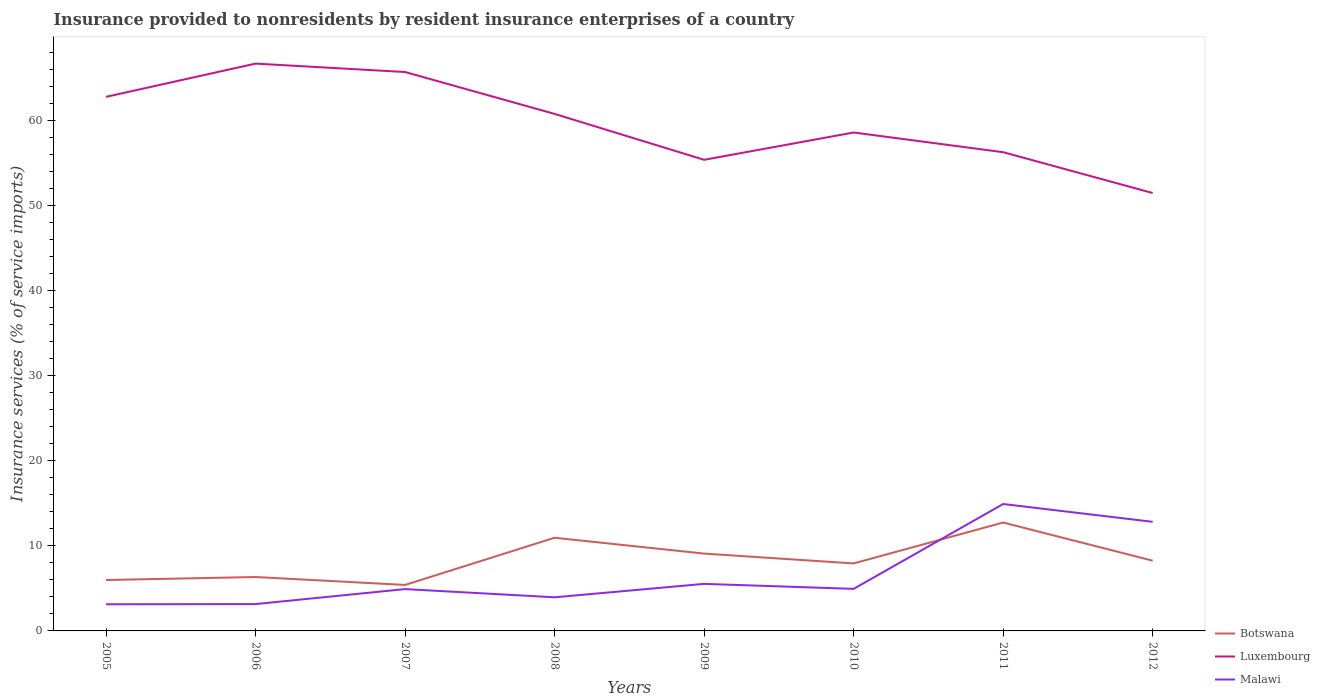How many different coloured lines are there?
Make the answer very short. 3. Across all years, what is the maximum insurance provided to nonresidents in Botswana?
Make the answer very short. 5.41. What is the total insurance provided to nonresidents in Malawi in the graph?
Provide a short and direct response. -11.77. What is the difference between the highest and the second highest insurance provided to nonresidents in Malawi?
Your response must be concise. 11.79. Is the insurance provided to nonresidents in Luxembourg strictly greater than the insurance provided to nonresidents in Malawi over the years?
Your response must be concise. No. What is the difference between two consecutive major ticks on the Y-axis?
Offer a very short reply. 10. Are the values on the major ticks of Y-axis written in scientific E-notation?
Your response must be concise. No. Does the graph contain any zero values?
Give a very brief answer. No. Where does the legend appear in the graph?
Provide a short and direct response. Bottom right. What is the title of the graph?
Your answer should be compact. Insurance provided to nonresidents by resident insurance enterprises of a country. What is the label or title of the Y-axis?
Your answer should be very brief. Insurance services (% of service imports). What is the Insurance services (% of service imports) of Botswana in 2005?
Give a very brief answer. 5.99. What is the Insurance services (% of service imports) in Luxembourg in 2005?
Keep it short and to the point. 62.82. What is the Insurance services (% of service imports) in Malawi in 2005?
Ensure brevity in your answer.  3.13. What is the Insurance services (% of service imports) in Botswana in 2006?
Offer a very short reply. 6.34. What is the Insurance services (% of service imports) in Luxembourg in 2006?
Offer a very short reply. 66.73. What is the Insurance services (% of service imports) of Malawi in 2006?
Make the answer very short. 3.16. What is the Insurance services (% of service imports) in Botswana in 2007?
Your answer should be very brief. 5.41. What is the Insurance services (% of service imports) in Luxembourg in 2007?
Ensure brevity in your answer.  65.74. What is the Insurance services (% of service imports) of Malawi in 2007?
Ensure brevity in your answer.  4.92. What is the Insurance services (% of service imports) in Botswana in 2008?
Give a very brief answer. 10.96. What is the Insurance services (% of service imports) of Luxembourg in 2008?
Provide a short and direct response. 60.81. What is the Insurance services (% of service imports) of Malawi in 2008?
Keep it short and to the point. 3.95. What is the Insurance services (% of service imports) in Botswana in 2009?
Offer a terse response. 9.1. What is the Insurance services (% of service imports) in Luxembourg in 2009?
Ensure brevity in your answer.  55.41. What is the Insurance services (% of service imports) in Malawi in 2009?
Provide a succinct answer. 5.53. What is the Insurance services (% of service imports) in Botswana in 2010?
Offer a very short reply. 7.94. What is the Insurance services (% of service imports) of Luxembourg in 2010?
Keep it short and to the point. 58.63. What is the Insurance services (% of service imports) in Malawi in 2010?
Your answer should be compact. 4.95. What is the Insurance services (% of service imports) of Botswana in 2011?
Offer a terse response. 12.75. What is the Insurance services (% of service imports) of Luxembourg in 2011?
Provide a succinct answer. 56.31. What is the Insurance services (% of service imports) of Malawi in 2011?
Offer a terse response. 14.93. What is the Insurance services (% of service imports) of Botswana in 2012?
Make the answer very short. 8.26. What is the Insurance services (% of service imports) in Luxembourg in 2012?
Your answer should be compact. 51.51. What is the Insurance services (% of service imports) in Malawi in 2012?
Keep it short and to the point. 12.83. Across all years, what is the maximum Insurance services (% of service imports) of Botswana?
Give a very brief answer. 12.75. Across all years, what is the maximum Insurance services (% of service imports) of Luxembourg?
Give a very brief answer. 66.73. Across all years, what is the maximum Insurance services (% of service imports) of Malawi?
Your response must be concise. 14.93. Across all years, what is the minimum Insurance services (% of service imports) of Botswana?
Keep it short and to the point. 5.41. Across all years, what is the minimum Insurance services (% of service imports) of Luxembourg?
Your response must be concise. 51.51. Across all years, what is the minimum Insurance services (% of service imports) in Malawi?
Offer a terse response. 3.13. What is the total Insurance services (% of service imports) in Botswana in the graph?
Your response must be concise. 66.74. What is the total Insurance services (% of service imports) of Luxembourg in the graph?
Provide a succinct answer. 477.96. What is the total Insurance services (% of service imports) in Malawi in the graph?
Make the answer very short. 53.41. What is the difference between the Insurance services (% of service imports) of Botswana in 2005 and that in 2006?
Provide a succinct answer. -0.35. What is the difference between the Insurance services (% of service imports) of Luxembourg in 2005 and that in 2006?
Ensure brevity in your answer.  -3.91. What is the difference between the Insurance services (% of service imports) in Malawi in 2005 and that in 2006?
Ensure brevity in your answer.  -0.02. What is the difference between the Insurance services (% of service imports) in Botswana in 2005 and that in 2007?
Give a very brief answer. 0.58. What is the difference between the Insurance services (% of service imports) of Luxembourg in 2005 and that in 2007?
Offer a very short reply. -2.92. What is the difference between the Insurance services (% of service imports) in Malawi in 2005 and that in 2007?
Your response must be concise. -1.78. What is the difference between the Insurance services (% of service imports) of Botswana in 2005 and that in 2008?
Your response must be concise. -4.97. What is the difference between the Insurance services (% of service imports) in Luxembourg in 2005 and that in 2008?
Give a very brief answer. 2.01. What is the difference between the Insurance services (% of service imports) in Malawi in 2005 and that in 2008?
Make the answer very short. -0.82. What is the difference between the Insurance services (% of service imports) of Botswana in 2005 and that in 2009?
Provide a short and direct response. -3.11. What is the difference between the Insurance services (% of service imports) in Luxembourg in 2005 and that in 2009?
Make the answer very short. 7.4. What is the difference between the Insurance services (% of service imports) of Malawi in 2005 and that in 2009?
Keep it short and to the point. -2.4. What is the difference between the Insurance services (% of service imports) in Botswana in 2005 and that in 2010?
Your response must be concise. -1.95. What is the difference between the Insurance services (% of service imports) in Luxembourg in 2005 and that in 2010?
Your answer should be compact. 4.19. What is the difference between the Insurance services (% of service imports) in Malawi in 2005 and that in 2010?
Provide a succinct answer. -1.81. What is the difference between the Insurance services (% of service imports) in Botswana in 2005 and that in 2011?
Give a very brief answer. -6.76. What is the difference between the Insurance services (% of service imports) of Luxembourg in 2005 and that in 2011?
Ensure brevity in your answer.  6.51. What is the difference between the Insurance services (% of service imports) of Malawi in 2005 and that in 2011?
Keep it short and to the point. -11.79. What is the difference between the Insurance services (% of service imports) in Botswana in 2005 and that in 2012?
Offer a terse response. -2.27. What is the difference between the Insurance services (% of service imports) of Luxembourg in 2005 and that in 2012?
Provide a short and direct response. 11.31. What is the difference between the Insurance services (% of service imports) in Malawi in 2005 and that in 2012?
Your response must be concise. -9.7. What is the difference between the Insurance services (% of service imports) in Botswana in 2006 and that in 2007?
Make the answer very short. 0.93. What is the difference between the Insurance services (% of service imports) of Luxembourg in 2006 and that in 2007?
Offer a terse response. 0.99. What is the difference between the Insurance services (% of service imports) in Malawi in 2006 and that in 2007?
Give a very brief answer. -1.76. What is the difference between the Insurance services (% of service imports) of Botswana in 2006 and that in 2008?
Give a very brief answer. -4.62. What is the difference between the Insurance services (% of service imports) of Luxembourg in 2006 and that in 2008?
Make the answer very short. 5.92. What is the difference between the Insurance services (% of service imports) of Malawi in 2006 and that in 2008?
Give a very brief answer. -0.8. What is the difference between the Insurance services (% of service imports) of Botswana in 2006 and that in 2009?
Offer a very short reply. -2.76. What is the difference between the Insurance services (% of service imports) of Luxembourg in 2006 and that in 2009?
Keep it short and to the point. 11.32. What is the difference between the Insurance services (% of service imports) in Malawi in 2006 and that in 2009?
Keep it short and to the point. -2.38. What is the difference between the Insurance services (% of service imports) of Botswana in 2006 and that in 2010?
Your response must be concise. -1.6. What is the difference between the Insurance services (% of service imports) of Luxembourg in 2006 and that in 2010?
Make the answer very short. 8.1. What is the difference between the Insurance services (% of service imports) of Malawi in 2006 and that in 2010?
Make the answer very short. -1.79. What is the difference between the Insurance services (% of service imports) in Botswana in 2006 and that in 2011?
Offer a terse response. -6.41. What is the difference between the Insurance services (% of service imports) in Luxembourg in 2006 and that in 2011?
Keep it short and to the point. 10.42. What is the difference between the Insurance services (% of service imports) of Malawi in 2006 and that in 2011?
Offer a terse response. -11.77. What is the difference between the Insurance services (% of service imports) in Botswana in 2006 and that in 2012?
Your response must be concise. -1.92. What is the difference between the Insurance services (% of service imports) of Luxembourg in 2006 and that in 2012?
Provide a succinct answer. 15.22. What is the difference between the Insurance services (% of service imports) of Malawi in 2006 and that in 2012?
Offer a terse response. -9.68. What is the difference between the Insurance services (% of service imports) in Botswana in 2007 and that in 2008?
Offer a terse response. -5.55. What is the difference between the Insurance services (% of service imports) of Luxembourg in 2007 and that in 2008?
Offer a very short reply. 4.93. What is the difference between the Insurance services (% of service imports) in Malawi in 2007 and that in 2008?
Your answer should be compact. 0.96. What is the difference between the Insurance services (% of service imports) in Botswana in 2007 and that in 2009?
Ensure brevity in your answer.  -3.69. What is the difference between the Insurance services (% of service imports) of Luxembourg in 2007 and that in 2009?
Ensure brevity in your answer.  10.33. What is the difference between the Insurance services (% of service imports) in Malawi in 2007 and that in 2009?
Give a very brief answer. -0.62. What is the difference between the Insurance services (% of service imports) in Botswana in 2007 and that in 2010?
Ensure brevity in your answer.  -2.53. What is the difference between the Insurance services (% of service imports) of Luxembourg in 2007 and that in 2010?
Offer a very short reply. 7.11. What is the difference between the Insurance services (% of service imports) of Malawi in 2007 and that in 2010?
Provide a succinct answer. -0.03. What is the difference between the Insurance services (% of service imports) in Botswana in 2007 and that in 2011?
Ensure brevity in your answer.  -7.34. What is the difference between the Insurance services (% of service imports) of Luxembourg in 2007 and that in 2011?
Make the answer very short. 9.43. What is the difference between the Insurance services (% of service imports) of Malawi in 2007 and that in 2011?
Make the answer very short. -10.01. What is the difference between the Insurance services (% of service imports) in Botswana in 2007 and that in 2012?
Keep it short and to the point. -2.85. What is the difference between the Insurance services (% of service imports) of Luxembourg in 2007 and that in 2012?
Offer a terse response. 14.23. What is the difference between the Insurance services (% of service imports) in Malawi in 2007 and that in 2012?
Offer a terse response. -7.91. What is the difference between the Insurance services (% of service imports) of Botswana in 2008 and that in 2009?
Offer a very short reply. 1.86. What is the difference between the Insurance services (% of service imports) in Luxembourg in 2008 and that in 2009?
Your response must be concise. 5.4. What is the difference between the Insurance services (% of service imports) in Malawi in 2008 and that in 2009?
Give a very brief answer. -1.58. What is the difference between the Insurance services (% of service imports) of Botswana in 2008 and that in 2010?
Provide a short and direct response. 3.02. What is the difference between the Insurance services (% of service imports) of Luxembourg in 2008 and that in 2010?
Provide a short and direct response. 2.19. What is the difference between the Insurance services (% of service imports) in Malawi in 2008 and that in 2010?
Keep it short and to the point. -0.99. What is the difference between the Insurance services (% of service imports) in Botswana in 2008 and that in 2011?
Ensure brevity in your answer.  -1.79. What is the difference between the Insurance services (% of service imports) in Luxembourg in 2008 and that in 2011?
Your answer should be compact. 4.5. What is the difference between the Insurance services (% of service imports) in Malawi in 2008 and that in 2011?
Provide a short and direct response. -10.97. What is the difference between the Insurance services (% of service imports) of Botswana in 2008 and that in 2012?
Your answer should be compact. 2.7. What is the difference between the Insurance services (% of service imports) in Luxembourg in 2008 and that in 2012?
Your answer should be compact. 9.31. What is the difference between the Insurance services (% of service imports) of Malawi in 2008 and that in 2012?
Your response must be concise. -8.88. What is the difference between the Insurance services (% of service imports) of Botswana in 2009 and that in 2010?
Your answer should be very brief. 1.16. What is the difference between the Insurance services (% of service imports) of Luxembourg in 2009 and that in 2010?
Ensure brevity in your answer.  -3.21. What is the difference between the Insurance services (% of service imports) of Malawi in 2009 and that in 2010?
Your response must be concise. 0.59. What is the difference between the Insurance services (% of service imports) of Botswana in 2009 and that in 2011?
Ensure brevity in your answer.  -3.65. What is the difference between the Insurance services (% of service imports) of Luxembourg in 2009 and that in 2011?
Your response must be concise. -0.9. What is the difference between the Insurance services (% of service imports) of Malawi in 2009 and that in 2011?
Keep it short and to the point. -9.39. What is the difference between the Insurance services (% of service imports) of Botswana in 2009 and that in 2012?
Your answer should be compact. 0.83. What is the difference between the Insurance services (% of service imports) of Luxembourg in 2009 and that in 2012?
Offer a very short reply. 3.91. What is the difference between the Insurance services (% of service imports) in Malawi in 2009 and that in 2012?
Provide a short and direct response. -7.3. What is the difference between the Insurance services (% of service imports) in Botswana in 2010 and that in 2011?
Your answer should be compact. -4.81. What is the difference between the Insurance services (% of service imports) in Luxembourg in 2010 and that in 2011?
Ensure brevity in your answer.  2.32. What is the difference between the Insurance services (% of service imports) of Malawi in 2010 and that in 2011?
Give a very brief answer. -9.98. What is the difference between the Insurance services (% of service imports) in Botswana in 2010 and that in 2012?
Offer a very short reply. -0.32. What is the difference between the Insurance services (% of service imports) of Luxembourg in 2010 and that in 2012?
Your response must be concise. 7.12. What is the difference between the Insurance services (% of service imports) in Malawi in 2010 and that in 2012?
Keep it short and to the point. -7.89. What is the difference between the Insurance services (% of service imports) of Botswana in 2011 and that in 2012?
Give a very brief answer. 4.49. What is the difference between the Insurance services (% of service imports) in Luxembourg in 2011 and that in 2012?
Keep it short and to the point. 4.8. What is the difference between the Insurance services (% of service imports) in Malawi in 2011 and that in 2012?
Make the answer very short. 2.09. What is the difference between the Insurance services (% of service imports) of Botswana in 2005 and the Insurance services (% of service imports) of Luxembourg in 2006?
Give a very brief answer. -60.74. What is the difference between the Insurance services (% of service imports) of Botswana in 2005 and the Insurance services (% of service imports) of Malawi in 2006?
Keep it short and to the point. 2.83. What is the difference between the Insurance services (% of service imports) of Luxembourg in 2005 and the Insurance services (% of service imports) of Malawi in 2006?
Keep it short and to the point. 59.66. What is the difference between the Insurance services (% of service imports) in Botswana in 2005 and the Insurance services (% of service imports) in Luxembourg in 2007?
Give a very brief answer. -59.75. What is the difference between the Insurance services (% of service imports) in Botswana in 2005 and the Insurance services (% of service imports) in Malawi in 2007?
Offer a terse response. 1.07. What is the difference between the Insurance services (% of service imports) in Luxembourg in 2005 and the Insurance services (% of service imports) in Malawi in 2007?
Keep it short and to the point. 57.9. What is the difference between the Insurance services (% of service imports) in Botswana in 2005 and the Insurance services (% of service imports) in Luxembourg in 2008?
Your answer should be compact. -54.83. What is the difference between the Insurance services (% of service imports) of Botswana in 2005 and the Insurance services (% of service imports) of Malawi in 2008?
Give a very brief answer. 2.03. What is the difference between the Insurance services (% of service imports) in Luxembourg in 2005 and the Insurance services (% of service imports) in Malawi in 2008?
Provide a short and direct response. 58.86. What is the difference between the Insurance services (% of service imports) of Botswana in 2005 and the Insurance services (% of service imports) of Luxembourg in 2009?
Give a very brief answer. -49.43. What is the difference between the Insurance services (% of service imports) in Botswana in 2005 and the Insurance services (% of service imports) in Malawi in 2009?
Keep it short and to the point. 0.45. What is the difference between the Insurance services (% of service imports) of Luxembourg in 2005 and the Insurance services (% of service imports) of Malawi in 2009?
Provide a short and direct response. 57.28. What is the difference between the Insurance services (% of service imports) of Botswana in 2005 and the Insurance services (% of service imports) of Luxembourg in 2010?
Offer a very short reply. -52.64. What is the difference between the Insurance services (% of service imports) of Botswana in 2005 and the Insurance services (% of service imports) of Malawi in 2010?
Make the answer very short. 1.04. What is the difference between the Insurance services (% of service imports) in Luxembourg in 2005 and the Insurance services (% of service imports) in Malawi in 2010?
Keep it short and to the point. 57.87. What is the difference between the Insurance services (% of service imports) in Botswana in 2005 and the Insurance services (% of service imports) in Luxembourg in 2011?
Your answer should be very brief. -50.32. What is the difference between the Insurance services (% of service imports) in Botswana in 2005 and the Insurance services (% of service imports) in Malawi in 2011?
Offer a very short reply. -8.94. What is the difference between the Insurance services (% of service imports) of Luxembourg in 2005 and the Insurance services (% of service imports) of Malawi in 2011?
Make the answer very short. 47.89. What is the difference between the Insurance services (% of service imports) in Botswana in 2005 and the Insurance services (% of service imports) in Luxembourg in 2012?
Offer a very short reply. -45.52. What is the difference between the Insurance services (% of service imports) of Botswana in 2005 and the Insurance services (% of service imports) of Malawi in 2012?
Your response must be concise. -6.85. What is the difference between the Insurance services (% of service imports) in Luxembourg in 2005 and the Insurance services (% of service imports) in Malawi in 2012?
Your answer should be very brief. 49.99. What is the difference between the Insurance services (% of service imports) in Botswana in 2006 and the Insurance services (% of service imports) in Luxembourg in 2007?
Your answer should be very brief. -59.4. What is the difference between the Insurance services (% of service imports) of Botswana in 2006 and the Insurance services (% of service imports) of Malawi in 2007?
Provide a short and direct response. 1.42. What is the difference between the Insurance services (% of service imports) in Luxembourg in 2006 and the Insurance services (% of service imports) in Malawi in 2007?
Your answer should be very brief. 61.81. What is the difference between the Insurance services (% of service imports) in Botswana in 2006 and the Insurance services (% of service imports) in Luxembourg in 2008?
Provide a short and direct response. -54.47. What is the difference between the Insurance services (% of service imports) of Botswana in 2006 and the Insurance services (% of service imports) of Malawi in 2008?
Provide a short and direct response. 2.39. What is the difference between the Insurance services (% of service imports) of Luxembourg in 2006 and the Insurance services (% of service imports) of Malawi in 2008?
Offer a terse response. 62.78. What is the difference between the Insurance services (% of service imports) of Botswana in 2006 and the Insurance services (% of service imports) of Luxembourg in 2009?
Provide a succinct answer. -49.07. What is the difference between the Insurance services (% of service imports) in Botswana in 2006 and the Insurance services (% of service imports) in Malawi in 2009?
Make the answer very short. 0.81. What is the difference between the Insurance services (% of service imports) in Luxembourg in 2006 and the Insurance services (% of service imports) in Malawi in 2009?
Provide a succinct answer. 61.2. What is the difference between the Insurance services (% of service imports) in Botswana in 2006 and the Insurance services (% of service imports) in Luxembourg in 2010?
Your answer should be compact. -52.29. What is the difference between the Insurance services (% of service imports) of Botswana in 2006 and the Insurance services (% of service imports) of Malawi in 2010?
Your response must be concise. 1.39. What is the difference between the Insurance services (% of service imports) in Luxembourg in 2006 and the Insurance services (% of service imports) in Malawi in 2010?
Ensure brevity in your answer.  61.78. What is the difference between the Insurance services (% of service imports) of Botswana in 2006 and the Insurance services (% of service imports) of Luxembourg in 2011?
Ensure brevity in your answer.  -49.97. What is the difference between the Insurance services (% of service imports) in Botswana in 2006 and the Insurance services (% of service imports) in Malawi in 2011?
Keep it short and to the point. -8.59. What is the difference between the Insurance services (% of service imports) in Luxembourg in 2006 and the Insurance services (% of service imports) in Malawi in 2011?
Provide a succinct answer. 51.8. What is the difference between the Insurance services (% of service imports) of Botswana in 2006 and the Insurance services (% of service imports) of Luxembourg in 2012?
Your answer should be compact. -45.17. What is the difference between the Insurance services (% of service imports) of Botswana in 2006 and the Insurance services (% of service imports) of Malawi in 2012?
Provide a short and direct response. -6.49. What is the difference between the Insurance services (% of service imports) in Luxembourg in 2006 and the Insurance services (% of service imports) in Malawi in 2012?
Give a very brief answer. 53.9. What is the difference between the Insurance services (% of service imports) in Botswana in 2007 and the Insurance services (% of service imports) in Luxembourg in 2008?
Your response must be concise. -55.41. What is the difference between the Insurance services (% of service imports) of Botswana in 2007 and the Insurance services (% of service imports) of Malawi in 2008?
Your response must be concise. 1.45. What is the difference between the Insurance services (% of service imports) of Luxembourg in 2007 and the Insurance services (% of service imports) of Malawi in 2008?
Your response must be concise. 61.79. What is the difference between the Insurance services (% of service imports) in Botswana in 2007 and the Insurance services (% of service imports) in Luxembourg in 2009?
Give a very brief answer. -50.01. What is the difference between the Insurance services (% of service imports) in Botswana in 2007 and the Insurance services (% of service imports) in Malawi in 2009?
Your answer should be very brief. -0.13. What is the difference between the Insurance services (% of service imports) in Luxembourg in 2007 and the Insurance services (% of service imports) in Malawi in 2009?
Make the answer very short. 60.21. What is the difference between the Insurance services (% of service imports) in Botswana in 2007 and the Insurance services (% of service imports) in Luxembourg in 2010?
Your response must be concise. -53.22. What is the difference between the Insurance services (% of service imports) of Botswana in 2007 and the Insurance services (% of service imports) of Malawi in 2010?
Make the answer very short. 0.46. What is the difference between the Insurance services (% of service imports) in Luxembourg in 2007 and the Insurance services (% of service imports) in Malawi in 2010?
Offer a very short reply. 60.79. What is the difference between the Insurance services (% of service imports) of Botswana in 2007 and the Insurance services (% of service imports) of Luxembourg in 2011?
Your response must be concise. -50.9. What is the difference between the Insurance services (% of service imports) in Botswana in 2007 and the Insurance services (% of service imports) in Malawi in 2011?
Your answer should be compact. -9.52. What is the difference between the Insurance services (% of service imports) in Luxembourg in 2007 and the Insurance services (% of service imports) in Malawi in 2011?
Offer a very short reply. 50.81. What is the difference between the Insurance services (% of service imports) in Botswana in 2007 and the Insurance services (% of service imports) in Luxembourg in 2012?
Your answer should be compact. -46.1. What is the difference between the Insurance services (% of service imports) of Botswana in 2007 and the Insurance services (% of service imports) of Malawi in 2012?
Provide a succinct answer. -7.42. What is the difference between the Insurance services (% of service imports) in Luxembourg in 2007 and the Insurance services (% of service imports) in Malawi in 2012?
Your answer should be very brief. 52.91. What is the difference between the Insurance services (% of service imports) in Botswana in 2008 and the Insurance services (% of service imports) in Luxembourg in 2009?
Keep it short and to the point. -44.46. What is the difference between the Insurance services (% of service imports) in Botswana in 2008 and the Insurance services (% of service imports) in Malawi in 2009?
Your answer should be very brief. 5.43. What is the difference between the Insurance services (% of service imports) in Luxembourg in 2008 and the Insurance services (% of service imports) in Malawi in 2009?
Make the answer very short. 55.28. What is the difference between the Insurance services (% of service imports) in Botswana in 2008 and the Insurance services (% of service imports) in Luxembourg in 2010?
Offer a terse response. -47.67. What is the difference between the Insurance services (% of service imports) of Botswana in 2008 and the Insurance services (% of service imports) of Malawi in 2010?
Provide a short and direct response. 6.01. What is the difference between the Insurance services (% of service imports) in Luxembourg in 2008 and the Insurance services (% of service imports) in Malawi in 2010?
Ensure brevity in your answer.  55.87. What is the difference between the Insurance services (% of service imports) of Botswana in 2008 and the Insurance services (% of service imports) of Luxembourg in 2011?
Offer a terse response. -45.35. What is the difference between the Insurance services (% of service imports) of Botswana in 2008 and the Insurance services (% of service imports) of Malawi in 2011?
Ensure brevity in your answer.  -3.97. What is the difference between the Insurance services (% of service imports) of Luxembourg in 2008 and the Insurance services (% of service imports) of Malawi in 2011?
Ensure brevity in your answer.  45.89. What is the difference between the Insurance services (% of service imports) of Botswana in 2008 and the Insurance services (% of service imports) of Luxembourg in 2012?
Ensure brevity in your answer.  -40.55. What is the difference between the Insurance services (% of service imports) of Botswana in 2008 and the Insurance services (% of service imports) of Malawi in 2012?
Keep it short and to the point. -1.87. What is the difference between the Insurance services (% of service imports) of Luxembourg in 2008 and the Insurance services (% of service imports) of Malawi in 2012?
Your answer should be compact. 47.98. What is the difference between the Insurance services (% of service imports) in Botswana in 2009 and the Insurance services (% of service imports) in Luxembourg in 2010?
Provide a succinct answer. -49.53. What is the difference between the Insurance services (% of service imports) of Botswana in 2009 and the Insurance services (% of service imports) of Malawi in 2010?
Provide a succinct answer. 4.15. What is the difference between the Insurance services (% of service imports) in Luxembourg in 2009 and the Insurance services (% of service imports) in Malawi in 2010?
Give a very brief answer. 50.47. What is the difference between the Insurance services (% of service imports) of Botswana in 2009 and the Insurance services (% of service imports) of Luxembourg in 2011?
Give a very brief answer. -47.21. What is the difference between the Insurance services (% of service imports) in Botswana in 2009 and the Insurance services (% of service imports) in Malawi in 2011?
Your answer should be very brief. -5.83. What is the difference between the Insurance services (% of service imports) of Luxembourg in 2009 and the Insurance services (% of service imports) of Malawi in 2011?
Your answer should be compact. 40.49. What is the difference between the Insurance services (% of service imports) in Botswana in 2009 and the Insurance services (% of service imports) in Luxembourg in 2012?
Your response must be concise. -42.41. What is the difference between the Insurance services (% of service imports) of Botswana in 2009 and the Insurance services (% of service imports) of Malawi in 2012?
Your response must be concise. -3.74. What is the difference between the Insurance services (% of service imports) in Luxembourg in 2009 and the Insurance services (% of service imports) in Malawi in 2012?
Provide a short and direct response. 42.58. What is the difference between the Insurance services (% of service imports) in Botswana in 2010 and the Insurance services (% of service imports) in Luxembourg in 2011?
Offer a terse response. -48.37. What is the difference between the Insurance services (% of service imports) of Botswana in 2010 and the Insurance services (% of service imports) of Malawi in 2011?
Provide a succinct answer. -6.99. What is the difference between the Insurance services (% of service imports) of Luxembourg in 2010 and the Insurance services (% of service imports) of Malawi in 2011?
Provide a short and direct response. 43.7. What is the difference between the Insurance services (% of service imports) of Botswana in 2010 and the Insurance services (% of service imports) of Luxembourg in 2012?
Offer a very short reply. -43.57. What is the difference between the Insurance services (% of service imports) in Botswana in 2010 and the Insurance services (% of service imports) in Malawi in 2012?
Provide a succinct answer. -4.89. What is the difference between the Insurance services (% of service imports) in Luxembourg in 2010 and the Insurance services (% of service imports) in Malawi in 2012?
Give a very brief answer. 45.79. What is the difference between the Insurance services (% of service imports) in Botswana in 2011 and the Insurance services (% of service imports) in Luxembourg in 2012?
Your response must be concise. -38.76. What is the difference between the Insurance services (% of service imports) of Botswana in 2011 and the Insurance services (% of service imports) of Malawi in 2012?
Ensure brevity in your answer.  -0.08. What is the difference between the Insurance services (% of service imports) of Luxembourg in 2011 and the Insurance services (% of service imports) of Malawi in 2012?
Your answer should be compact. 43.48. What is the average Insurance services (% of service imports) in Botswana per year?
Offer a terse response. 8.34. What is the average Insurance services (% of service imports) of Luxembourg per year?
Provide a short and direct response. 59.75. What is the average Insurance services (% of service imports) of Malawi per year?
Keep it short and to the point. 6.68. In the year 2005, what is the difference between the Insurance services (% of service imports) in Botswana and Insurance services (% of service imports) in Luxembourg?
Offer a terse response. -56.83. In the year 2005, what is the difference between the Insurance services (% of service imports) in Botswana and Insurance services (% of service imports) in Malawi?
Your answer should be very brief. 2.85. In the year 2005, what is the difference between the Insurance services (% of service imports) of Luxembourg and Insurance services (% of service imports) of Malawi?
Keep it short and to the point. 59.68. In the year 2006, what is the difference between the Insurance services (% of service imports) of Botswana and Insurance services (% of service imports) of Luxembourg?
Provide a succinct answer. -60.39. In the year 2006, what is the difference between the Insurance services (% of service imports) of Botswana and Insurance services (% of service imports) of Malawi?
Offer a very short reply. 3.18. In the year 2006, what is the difference between the Insurance services (% of service imports) of Luxembourg and Insurance services (% of service imports) of Malawi?
Provide a succinct answer. 63.57. In the year 2007, what is the difference between the Insurance services (% of service imports) in Botswana and Insurance services (% of service imports) in Luxembourg?
Give a very brief answer. -60.33. In the year 2007, what is the difference between the Insurance services (% of service imports) in Botswana and Insurance services (% of service imports) in Malawi?
Keep it short and to the point. 0.49. In the year 2007, what is the difference between the Insurance services (% of service imports) in Luxembourg and Insurance services (% of service imports) in Malawi?
Your response must be concise. 60.82. In the year 2008, what is the difference between the Insurance services (% of service imports) of Botswana and Insurance services (% of service imports) of Luxembourg?
Make the answer very short. -49.85. In the year 2008, what is the difference between the Insurance services (% of service imports) of Botswana and Insurance services (% of service imports) of Malawi?
Your response must be concise. 7. In the year 2008, what is the difference between the Insurance services (% of service imports) in Luxembourg and Insurance services (% of service imports) in Malawi?
Keep it short and to the point. 56.86. In the year 2009, what is the difference between the Insurance services (% of service imports) of Botswana and Insurance services (% of service imports) of Luxembourg?
Give a very brief answer. -46.32. In the year 2009, what is the difference between the Insurance services (% of service imports) of Botswana and Insurance services (% of service imports) of Malawi?
Give a very brief answer. 3.56. In the year 2009, what is the difference between the Insurance services (% of service imports) in Luxembourg and Insurance services (% of service imports) in Malawi?
Your answer should be compact. 49.88. In the year 2010, what is the difference between the Insurance services (% of service imports) in Botswana and Insurance services (% of service imports) in Luxembourg?
Offer a very short reply. -50.69. In the year 2010, what is the difference between the Insurance services (% of service imports) in Botswana and Insurance services (% of service imports) in Malawi?
Offer a terse response. 2.99. In the year 2010, what is the difference between the Insurance services (% of service imports) of Luxembourg and Insurance services (% of service imports) of Malawi?
Make the answer very short. 53.68. In the year 2011, what is the difference between the Insurance services (% of service imports) of Botswana and Insurance services (% of service imports) of Luxembourg?
Offer a very short reply. -43.56. In the year 2011, what is the difference between the Insurance services (% of service imports) of Botswana and Insurance services (% of service imports) of Malawi?
Keep it short and to the point. -2.18. In the year 2011, what is the difference between the Insurance services (% of service imports) in Luxembourg and Insurance services (% of service imports) in Malawi?
Your response must be concise. 41.38. In the year 2012, what is the difference between the Insurance services (% of service imports) of Botswana and Insurance services (% of service imports) of Luxembourg?
Your answer should be very brief. -43.25. In the year 2012, what is the difference between the Insurance services (% of service imports) in Botswana and Insurance services (% of service imports) in Malawi?
Keep it short and to the point. -4.57. In the year 2012, what is the difference between the Insurance services (% of service imports) of Luxembourg and Insurance services (% of service imports) of Malawi?
Provide a short and direct response. 38.67. What is the ratio of the Insurance services (% of service imports) of Botswana in 2005 to that in 2006?
Keep it short and to the point. 0.94. What is the ratio of the Insurance services (% of service imports) of Luxembourg in 2005 to that in 2006?
Offer a very short reply. 0.94. What is the ratio of the Insurance services (% of service imports) in Malawi in 2005 to that in 2006?
Provide a succinct answer. 0.99. What is the ratio of the Insurance services (% of service imports) of Botswana in 2005 to that in 2007?
Provide a short and direct response. 1.11. What is the ratio of the Insurance services (% of service imports) of Luxembourg in 2005 to that in 2007?
Provide a succinct answer. 0.96. What is the ratio of the Insurance services (% of service imports) in Malawi in 2005 to that in 2007?
Offer a very short reply. 0.64. What is the ratio of the Insurance services (% of service imports) of Botswana in 2005 to that in 2008?
Your answer should be very brief. 0.55. What is the ratio of the Insurance services (% of service imports) of Luxembourg in 2005 to that in 2008?
Make the answer very short. 1.03. What is the ratio of the Insurance services (% of service imports) of Malawi in 2005 to that in 2008?
Your answer should be very brief. 0.79. What is the ratio of the Insurance services (% of service imports) in Botswana in 2005 to that in 2009?
Your response must be concise. 0.66. What is the ratio of the Insurance services (% of service imports) in Luxembourg in 2005 to that in 2009?
Offer a very short reply. 1.13. What is the ratio of the Insurance services (% of service imports) of Malawi in 2005 to that in 2009?
Offer a terse response. 0.57. What is the ratio of the Insurance services (% of service imports) of Botswana in 2005 to that in 2010?
Offer a very short reply. 0.75. What is the ratio of the Insurance services (% of service imports) in Luxembourg in 2005 to that in 2010?
Your answer should be compact. 1.07. What is the ratio of the Insurance services (% of service imports) of Malawi in 2005 to that in 2010?
Give a very brief answer. 0.63. What is the ratio of the Insurance services (% of service imports) of Botswana in 2005 to that in 2011?
Provide a succinct answer. 0.47. What is the ratio of the Insurance services (% of service imports) of Luxembourg in 2005 to that in 2011?
Provide a short and direct response. 1.12. What is the ratio of the Insurance services (% of service imports) of Malawi in 2005 to that in 2011?
Your answer should be very brief. 0.21. What is the ratio of the Insurance services (% of service imports) of Botswana in 2005 to that in 2012?
Your answer should be very brief. 0.72. What is the ratio of the Insurance services (% of service imports) in Luxembourg in 2005 to that in 2012?
Your response must be concise. 1.22. What is the ratio of the Insurance services (% of service imports) of Malawi in 2005 to that in 2012?
Provide a short and direct response. 0.24. What is the ratio of the Insurance services (% of service imports) of Botswana in 2006 to that in 2007?
Provide a succinct answer. 1.17. What is the ratio of the Insurance services (% of service imports) in Luxembourg in 2006 to that in 2007?
Give a very brief answer. 1.01. What is the ratio of the Insurance services (% of service imports) of Malawi in 2006 to that in 2007?
Your response must be concise. 0.64. What is the ratio of the Insurance services (% of service imports) in Botswana in 2006 to that in 2008?
Provide a short and direct response. 0.58. What is the ratio of the Insurance services (% of service imports) of Luxembourg in 2006 to that in 2008?
Make the answer very short. 1.1. What is the ratio of the Insurance services (% of service imports) of Malawi in 2006 to that in 2008?
Your response must be concise. 0.8. What is the ratio of the Insurance services (% of service imports) of Botswana in 2006 to that in 2009?
Your answer should be compact. 0.7. What is the ratio of the Insurance services (% of service imports) of Luxembourg in 2006 to that in 2009?
Offer a terse response. 1.2. What is the ratio of the Insurance services (% of service imports) of Malawi in 2006 to that in 2009?
Keep it short and to the point. 0.57. What is the ratio of the Insurance services (% of service imports) in Botswana in 2006 to that in 2010?
Ensure brevity in your answer.  0.8. What is the ratio of the Insurance services (% of service imports) of Luxembourg in 2006 to that in 2010?
Keep it short and to the point. 1.14. What is the ratio of the Insurance services (% of service imports) in Malawi in 2006 to that in 2010?
Provide a succinct answer. 0.64. What is the ratio of the Insurance services (% of service imports) in Botswana in 2006 to that in 2011?
Offer a terse response. 0.5. What is the ratio of the Insurance services (% of service imports) in Luxembourg in 2006 to that in 2011?
Make the answer very short. 1.19. What is the ratio of the Insurance services (% of service imports) in Malawi in 2006 to that in 2011?
Offer a very short reply. 0.21. What is the ratio of the Insurance services (% of service imports) of Botswana in 2006 to that in 2012?
Your answer should be compact. 0.77. What is the ratio of the Insurance services (% of service imports) of Luxembourg in 2006 to that in 2012?
Your response must be concise. 1.3. What is the ratio of the Insurance services (% of service imports) of Malawi in 2006 to that in 2012?
Provide a short and direct response. 0.25. What is the ratio of the Insurance services (% of service imports) in Botswana in 2007 to that in 2008?
Your response must be concise. 0.49. What is the ratio of the Insurance services (% of service imports) in Luxembourg in 2007 to that in 2008?
Offer a very short reply. 1.08. What is the ratio of the Insurance services (% of service imports) of Malawi in 2007 to that in 2008?
Offer a terse response. 1.24. What is the ratio of the Insurance services (% of service imports) of Botswana in 2007 to that in 2009?
Provide a succinct answer. 0.59. What is the ratio of the Insurance services (% of service imports) in Luxembourg in 2007 to that in 2009?
Make the answer very short. 1.19. What is the ratio of the Insurance services (% of service imports) in Malawi in 2007 to that in 2009?
Make the answer very short. 0.89. What is the ratio of the Insurance services (% of service imports) in Botswana in 2007 to that in 2010?
Offer a very short reply. 0.68. What is the ratio of the Insurance services (% of service imports) in Luxembourg in 2007 to that in 2010?
Give a very brief answer. 1.12. What is the ratio of the Insurance services (% of service imports) in Malawi in 2007 to that in 2010?
Your response must be concise. 0.99. What is the ratio of the Insurance services (% of service imports) of Botswana in 2007 to that in 2011?
Make the answer very short. 0.42. What is the ratio of the Insurance services (% of service imports) in Luxembourg in 2007 to that in 2011?
Provide a short and direct response. 1.17. What is the ratio of the Insurance services (% of service imports) in Malawi in 2007 to that in 2011?
Give a very brief answer. 0.33. What is the ratio of the Insurance services (% of service imports) of Botswana in 2007 to that in 2012?
Make the answer very short. 0.65. What is the ratio of the Insurance services (% of service imports) of Luxembourg in 2007 to that in 2012?
Make the answer very short. 1.28. What is the ratio of the Insurance services (% of service imports) of Malawi in 2007 to that in 2012?
Your answer should be compact. 0.38. What is the ratio of the Insurance services (% of service imports) in Botswana in 2008 to that in 2009?
Provide a succinct answer. 1.2. What is the ratio of the Insurance services (% of service imports) of Luxembourg in 2008 to that in 2009?
Give a very brief answer. 1.1. What is the ratio of the Insurance services (% of service imports) of Malawi in 2008 to that in 2009?
Offer a terse response. 0.71. What is the ratio of the Insurance services (% of service imports) in Botswana in 2008 to that in 2010?
Offer a terse response. 1.38. What is the ratio of the Insurance services (% of service imports) in Luxembourg in 2008 to that in 2010?
Make the answer very short. 1.04. What is the ratio of the Insurance services (% of service imports) in Malawi in 2008 to that in 2010?
Ensure brevity in your answer.  0.8. What is the ratio of the Insurance services (% of service imports) in Botswana in 2008 to that in 2011?
Your answer should be compact. 0.86. What is the ratio of the Insurance services (% of service imports) of Malawi in 2008 to that in 2011?
Provide a succinct answer. 0.26. What is the ratio of the Insurance services (% of service imports) in Botswana in 2008 to that in 2012?
Ensure brevity in your answer.  1.33. What is the ratio of the Insurance services (% of service imports) of Luxembourg in 2008 to that in 2012?
Provide a short and direct response. 1.18. What is the ratio of the Insurance services (% of service imports) of Malawi in 2008 to that in 2012?
Your response must be concise. 0.31. What is the ratio of the Insurance services (% of service imports) in Botswana in 2009 to that in 2010?
Make the answer very short. 1.15. What is the ratio of the Insurance services (% of service imports) of Luxembourg in 2009 to that in 2010?
Provide a succinct answer. 0.95. What is the ratio of the Insurance services (% of service imports) of Malawi in 2009 to that in 2010?
Offer a terse response. 1.12. What is the ratio of the Insurance services (% of service imports) in Botswana in 2009 to that in 2011?
Your response must be concise. 0.71. What is the ratio of the Insurance services (% of service imports) of Luxembourg in 2009 to that in 2011?
Provide a succinct answer. 0.98. What is the ratio of the Insurance services (% of service imports) in Malawi in 2009 to that in 2011?
Your answer should be compact. 0.37. What is the ratio of the Insurance services (% of service imports) in Botswana in 2009 to that in 2012?
Make the answer very short. 1.1. What is the ratio of the Insurance services (% of service imports) in Luxembourg in 2009 to that in 2012?
Ensure brevity in your answer.  1.08. What is the ratio of the Insurance services (% of service imports) in Malawi in 2009 to that in 2012?
Give a very brief answer. 0.43. What is the ratio of the Insurance services (% of service imports) in Botswana in 2010 to that in 2011?
Keep it short and to the point. 0.62. What is the ratio of the Insurance services (% of service imports) of Luxembourg in 2010 to that in 2011?
Your answer should be very brief. 1.04. What is the ratio of the Insurance services (% of service imports) in Malawi in 2010 to that in 2011?
Offer a very short reply. 0.33. What is the ratio of the Insurance services (% of service imports) of Botswana in 2010 to that in 2012?
Offer a very short reply. 0.96. What is the ratio of the Insurance services (% of service imports) in Luxembourg in 2010 to that in 2012?
Provide a short and direct response. 1.14. What is the ratio of the Insurance services (% of service imports) in Malawi in 2010 to that in 2012?
Your answer should be compact. 0.39. What is the ratio of the Insurance services (% of service imports) of Botswana in 2011 to that in 2012?
Ensure brevity in your answer.  1.54. What is the ratio of the Insurance services (% of service imports) in Luxembourg in 2011 to that in 2012?
Keep it short and to the point. 1.09. What is the ratio of the Insurance services (% of service imports) of Malawi in 2011 to that in 2012?
Offer a terse response. 1.16. What is the difference between the highest and the second highest Insurance services (% of service imports) in Botswana?
Give a very brief answer. 1.79. What is the difference between the highest and the second highest Insurance services (% of service imports) in Luxembourg?
Your answer should be very brief. 0.99. What is the difference between the highest and the second highest Insurance services (% of service imports) in Malawi?
Offer a terse response. 2.09. What is the difference between the highest and the lowest Insurance services (% of service imports) in Botswana?
Offer a very short reply. 7.34. What is the difference between the highest and the lowest Insurance services (% of service imports) of Luxembourg?
Provide a short and direct response. 15.22. What is the difference between the highest and the lowest Insurance services (% of service imports) of Malawi?
Provide a succinct answer. 11.79. 